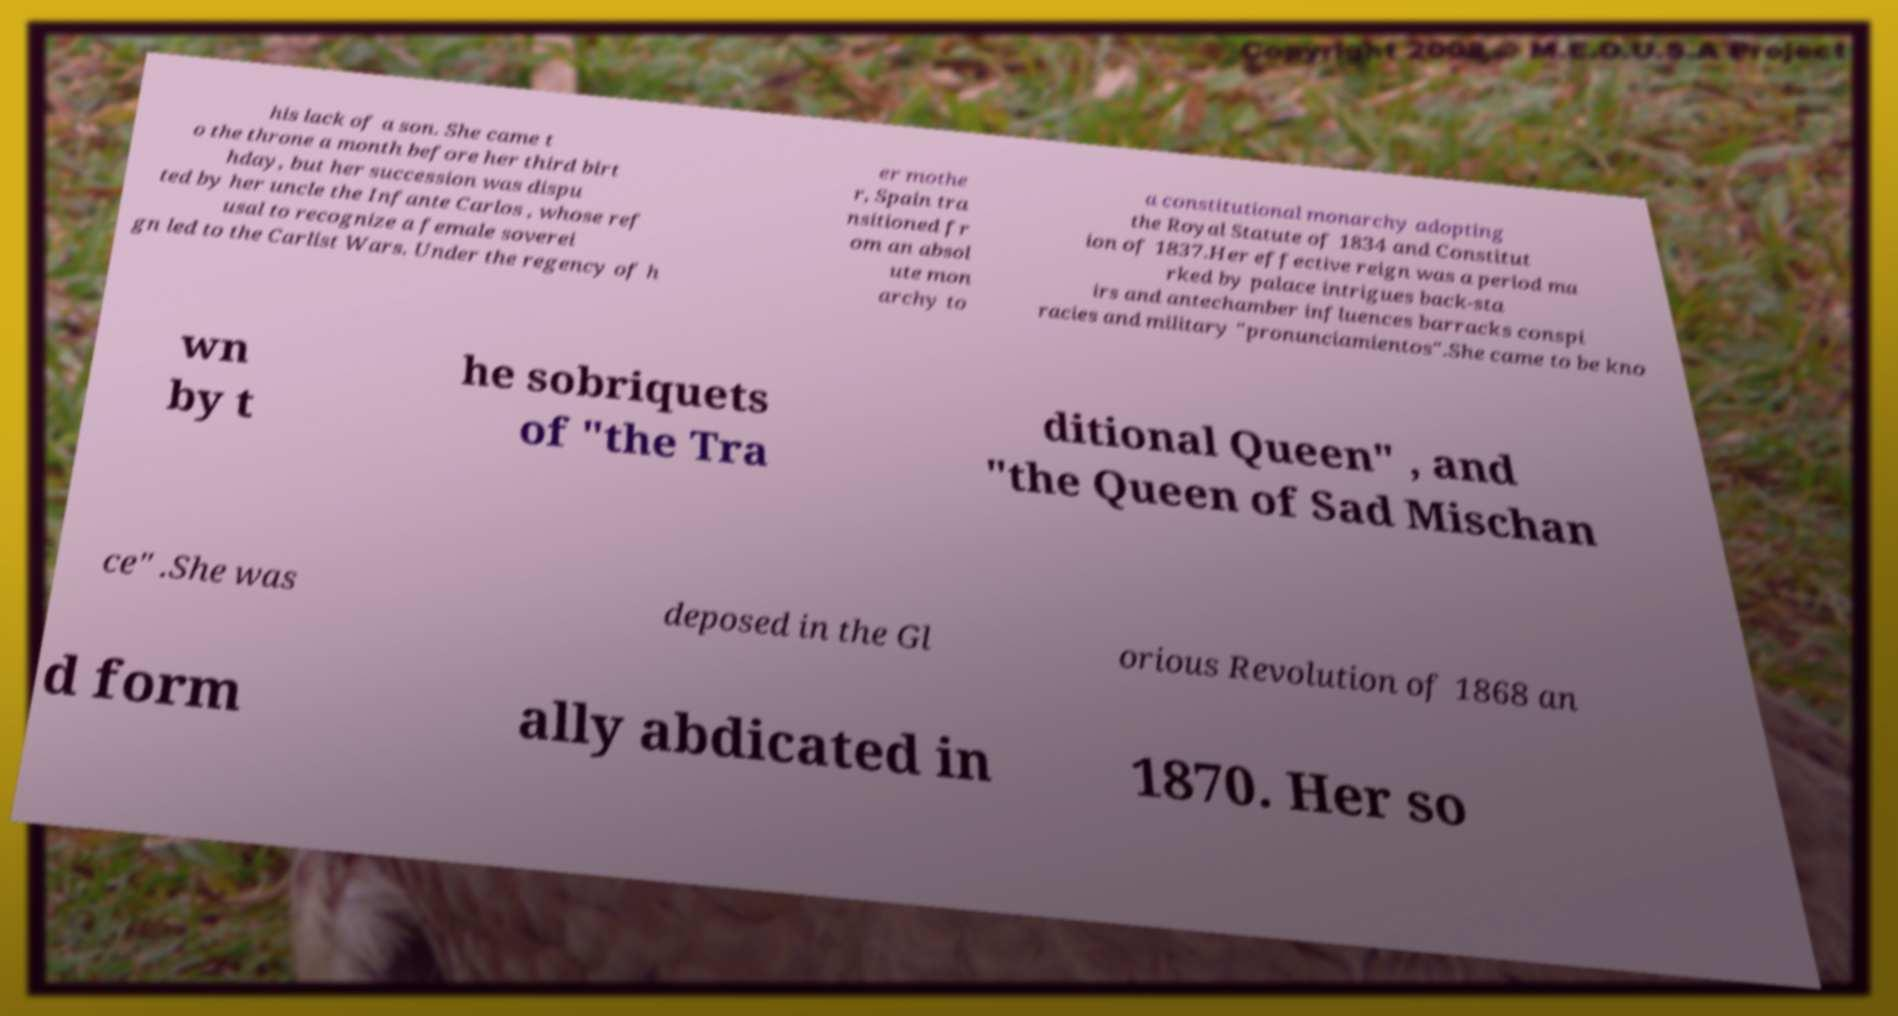Please read and relay the text visible in this image. What does it say? his lack of a son. She came t o the throne a month before her third birt hday, but her succession was dispu ted by her uncle the Infante Carlos , whose ref usal to recognize a female soverei gn led to the Carlist Wars. Under the regency of h er mothe r, Spain tra nsitioned fr om an absol ute mon archy to a constitutional monarchy adopting the Royal Statute of 1834 and Constitut ion of 1837.Her effective reign was a period ma rked by palace intrigues back-sta irs and antechamber influences barracks conspi racies and military "pronunciamientos".She came to be kno wn by t he sobriquets of "the Tra ditional Queen" , and "the Queen of Sad Mischan ce" .She was deposed in the Gl orious Revolution of 1868 an d form ally abdicated in 1870. Her so 